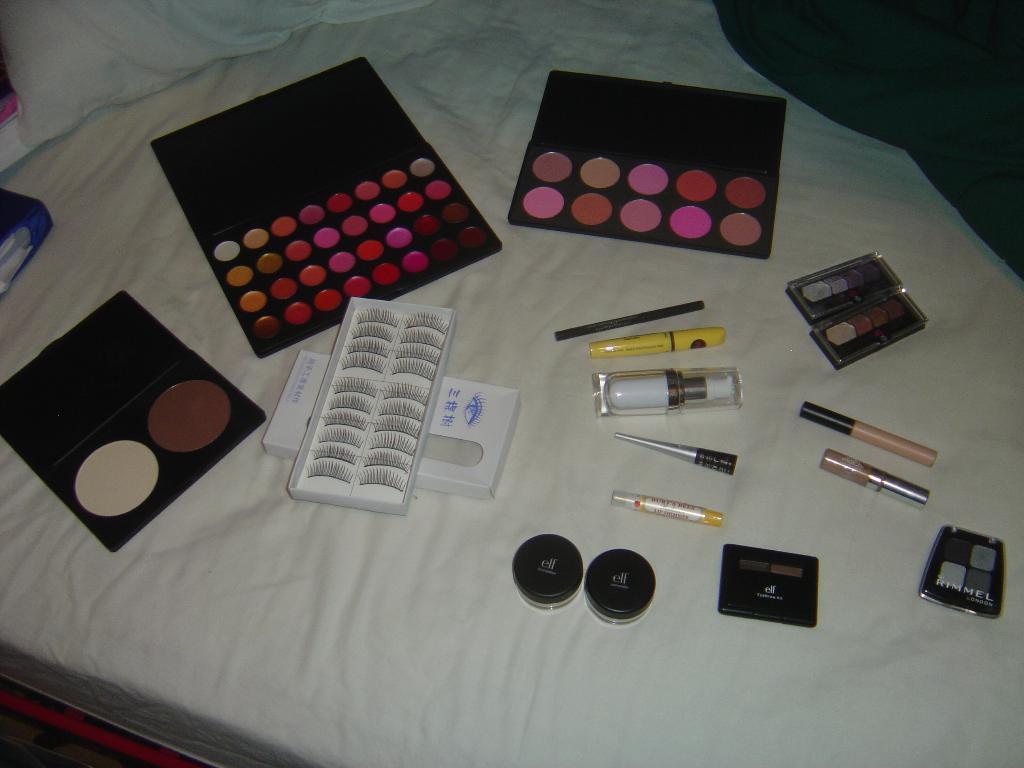In one or two sentences, can you explain what this image depicts? In this image, we can see makeup kit, eyelashes box, bottles are placed on the white bed. Top of the image, we can see a pillow. Here there is a cloth. 